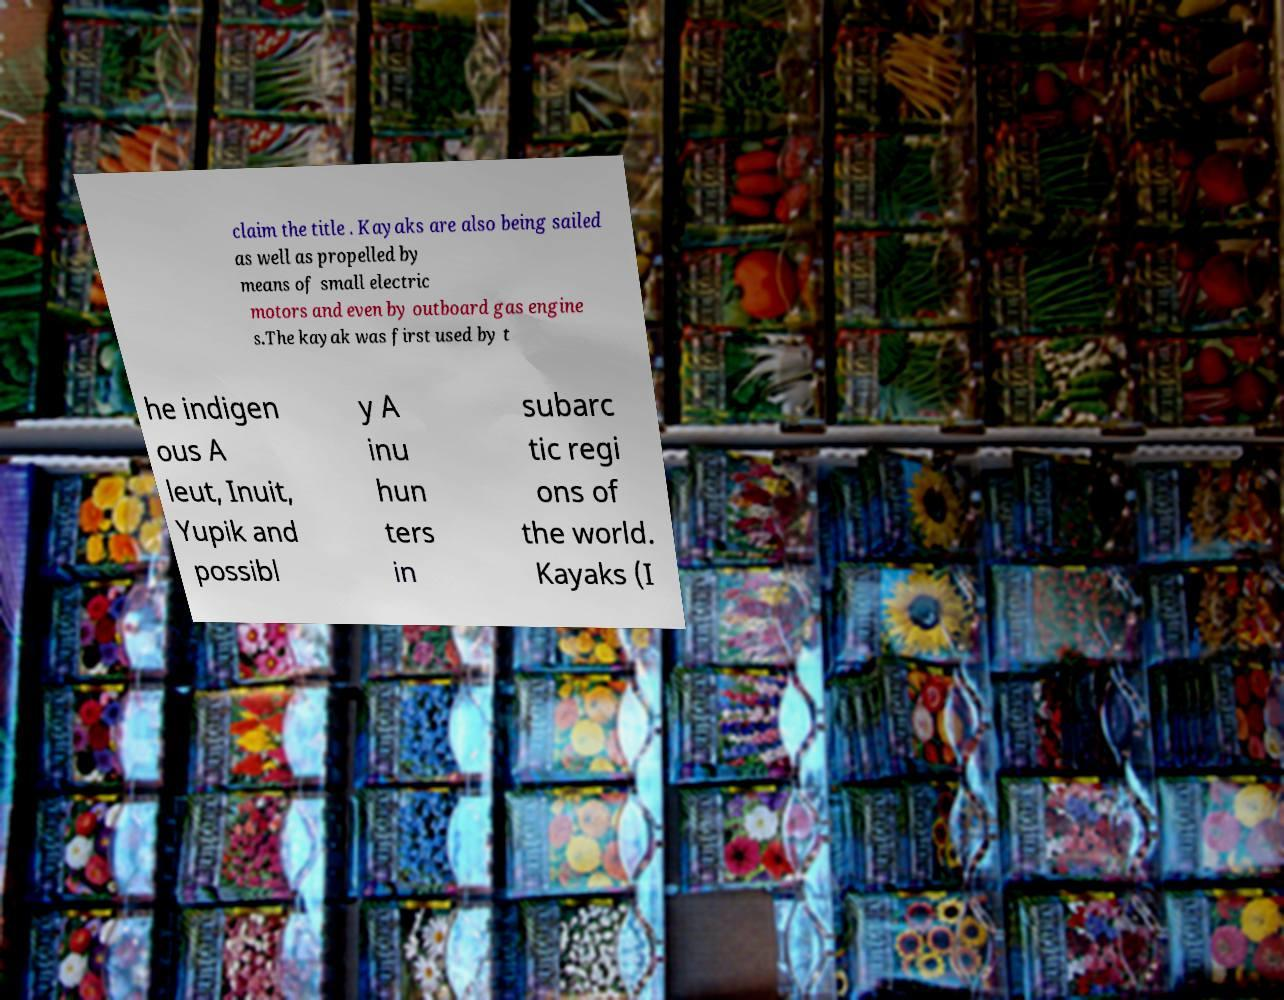Can you accurately transcribe the text from the provided image for me? claim the title . Kayaks are also being sailed as well as propelled by means of small electric motors and even by outboard gas engine s.The kayak was first used by t he indigen ous A leut, Inuit, Yupik and possibl y A inu hun ters in subarc tic regi ons of the world. Kayaks (I 